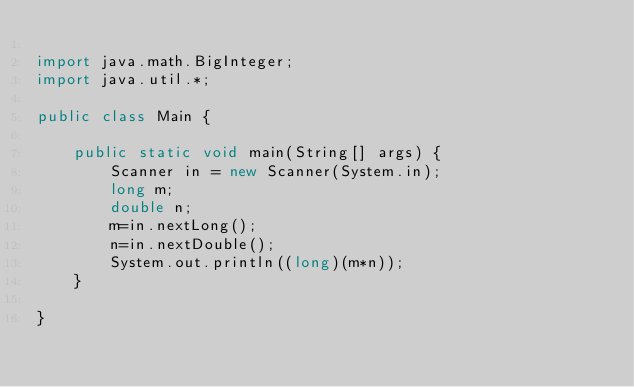<code> <loc_0><loc_0><loc_500><loc_500><_Java_>
import java.math.BigInteger;
import java.util.*;

public class Main {

    public static void main(String[] args) {
        Scanner in = new Scanner(System.in);
        long m;
        double n;
        m=in.nextLong();
        n=in.nextDouble();
        System.out.println((long)(m*n));
    }

}










</code> 